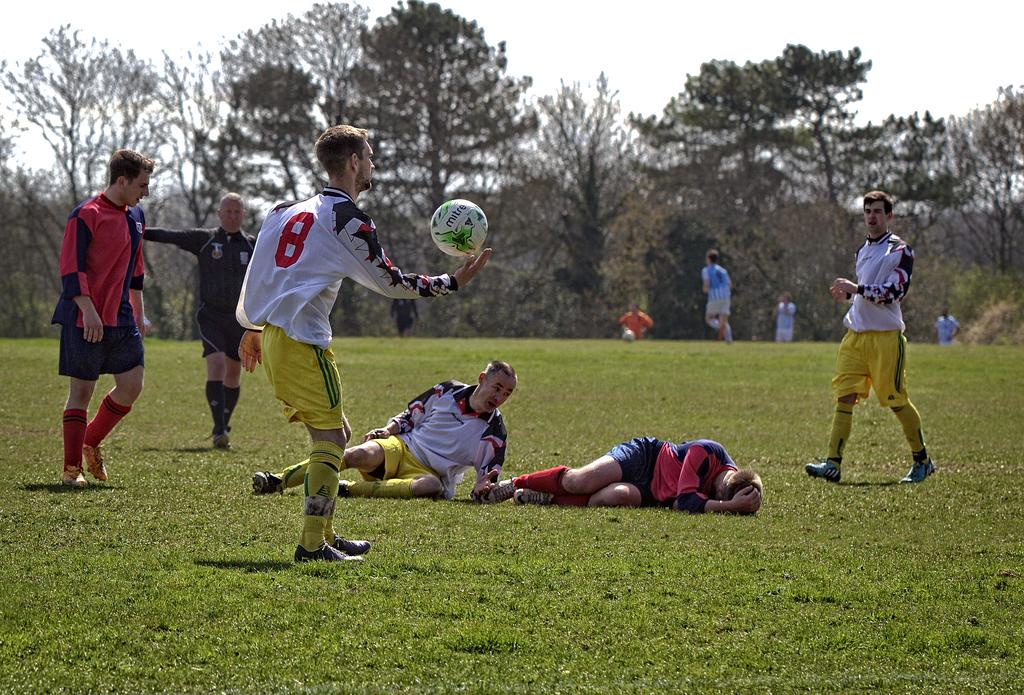Who or what is present in the image? There are people in the image. What object can be seen with the people? There is a white color football in the image. What type of surface are the people and the football on? There is grass in the image. What else can be seen in the background of the image? There are trees in the image. What is visible at the top of the image? The sky is visible at the top of the image. How many cows are present in the image? There are no cows present in the image. What type of skin condition can be seen on the people in the image? There is no indication of any skin condition on the people in the image. 